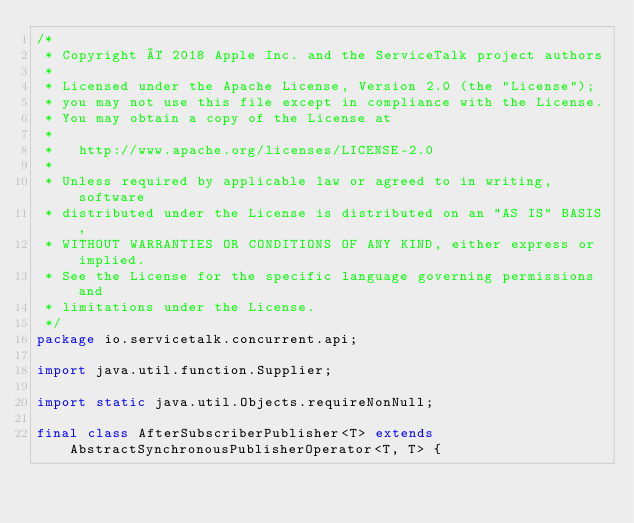<code> <loc_0><loc_0><loc_500><loc_500><_Java_>/*
 * Copyright © 2018 Apple Inc. and the ServiceTalk project authors
 *
 * Licensed under the Apache License, Version 2.0 (the "License");
 * you may not use this file except in compliance with the License.
 * You may obtain a copy of the License at
 *
 *   http://www.apache.org/licenses/LICENSE-2.0
 *
 * Unless required by applicable law or agreed to in writing, software
 * distributed under the License is distributed on an "AS IS" BASIS,
 * WITHOUT WARRANTIES OR CONDITIONS OF ANY KIND, either express or implied.
 * See the License for the specific language governing permissions and
 * limitations under the License.
 */
package io.servicetalk.concurrent.api;

import java.util.function.Supplier;

import static java.util.Objects.requireNonNull;

final class AfterSubscriberPublisher<T> extends AbstractSynchronousPublisherOperator<T, T> {</code> 